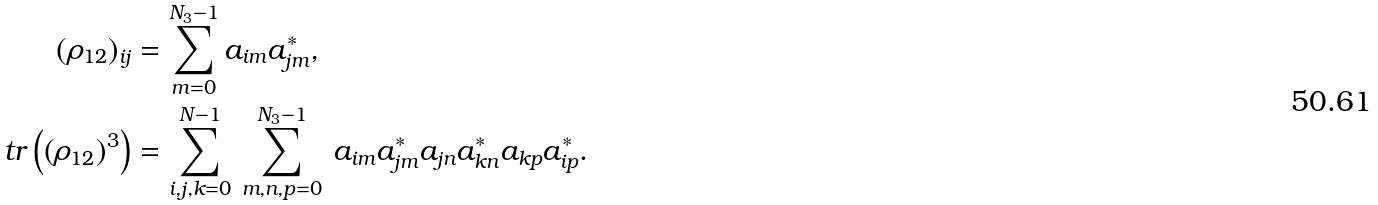<formula> <loc_0><loc_0><loc_500><loc_500>( \rho _ { 1 2 } ) _ { i j } & = \sum _ { m = 0 } ^ { N _ { 3 } - 1 } a _ { i m } a _ { j m } ^ { * } , \\ t r \left ( \left ( \rho _ { 1 2 } \right ) ^ { 3 } \right ) & = \sum _ { i , j , k = 0 } ^ { N - 1 } \, \sum _ { m , n , p = 0 } ^ { N _ { 3 } - 1 } \, a _ { i m } a _ { j m } ^ { * } a _ { j n } a _ { k n } ^ { * } a _ { k p } a _ { i p } ^ { * } .</formula> 